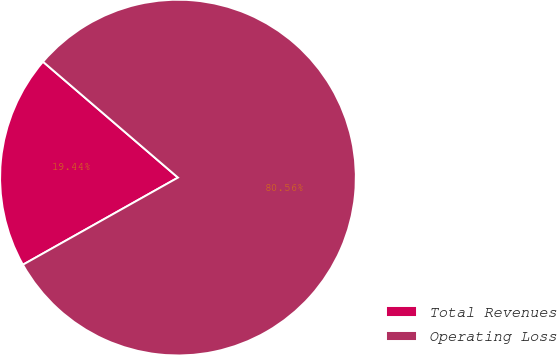Convert chart to OTSL. <chart><loc_0><loc_0><loc_500><loc_500><pie_chart><fcel>Total Revenues<fcel>Operating Loss<nl><fcel>19.44%<fcel>80.56%<nl></chart> 